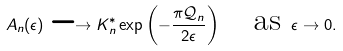<formula> <loc_0><loc_0><loc_500><loc_500>A _ { n } ( \epsilon ) \longrightarrow K _ { n } ^ { * } \exp \left ( - \frac { \pi \mathcal { Q } _ { n } } { 2 \epsilon } \right ) \quad \text {as} \ \epsilon \to 0 .</formula> 